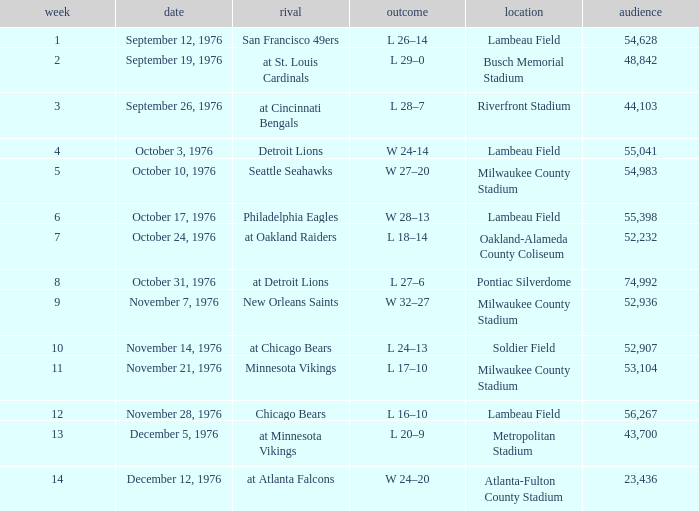Parse the full table. {'header': ['week', 'date', 'rival', 'outcome', 'location', 'audience'], 'rows': [['1', 'September 12, 1976', 'San Francisco 49ers', 'L 26–14', 'Lambeau Field', '54,628'], ['2', 'September 19, 1976', 'at St. Louis Cardinals', 'L 29–0', 'Busch Memorial Stadium', '48,842'], ['3', 'September 26, 1976', 'at Cincinnati Bengals', 'L 28–7', 'Riverfront Stadium', '44,103'], ['4', 'October 3, 1976', 'Detroit Lions', 'W 24-14', 'Lambeau Field', '55,041'], ['5', 'October 10, 1976', 'Seattle Seahawks', 'W 27–20', 'Milwaukee County Stadium', '54,983'], ['6', 'October 17, 1976', 'Philadelphia Eagles', 'W 28–13', 'Lambeau Field', '55,398'], ['7', 'October 24, 1976', 'at Oakland Raiders', 'L 18–14', 'Oakland-Alameda County Coliseum', '52,232'], ['8', 'October 31, 1976', 'at Detroit Lions', 'L 27–6', 'Pontiac Silverdome', '74,992'], ['9', 'November 7, 1976', 'New Orleans Saints', 'W 32–27', 'Milwaukee County Stadium', '52,936'], ['10', 'November 14, 1976', 'at Chicago Bears', 'L 24–13', 'Soldier Field', '52,907'], ['11', 'November 21, 1976', 'Minnesota Vikings', 'L 17–10', 'Milwaukee County Stadium', '53,104'], ['12', 'November 28, 1976', 'Chicago Bears', 'L 16–10', 'Lambeau Field', '56,267'], ['13', 'December 5, 1976', 'at Minnesota Vikings', 'L 20–9', 'Metropolitan Stadium', '43,700'], ['14', 'December 12, 1976', 'at Atlanta Falcons', 'W 24–20', 'Atlanta-Fulton County Stadium', '23,436']]} How many people attended the game on September 19, 1976? 1.0. 